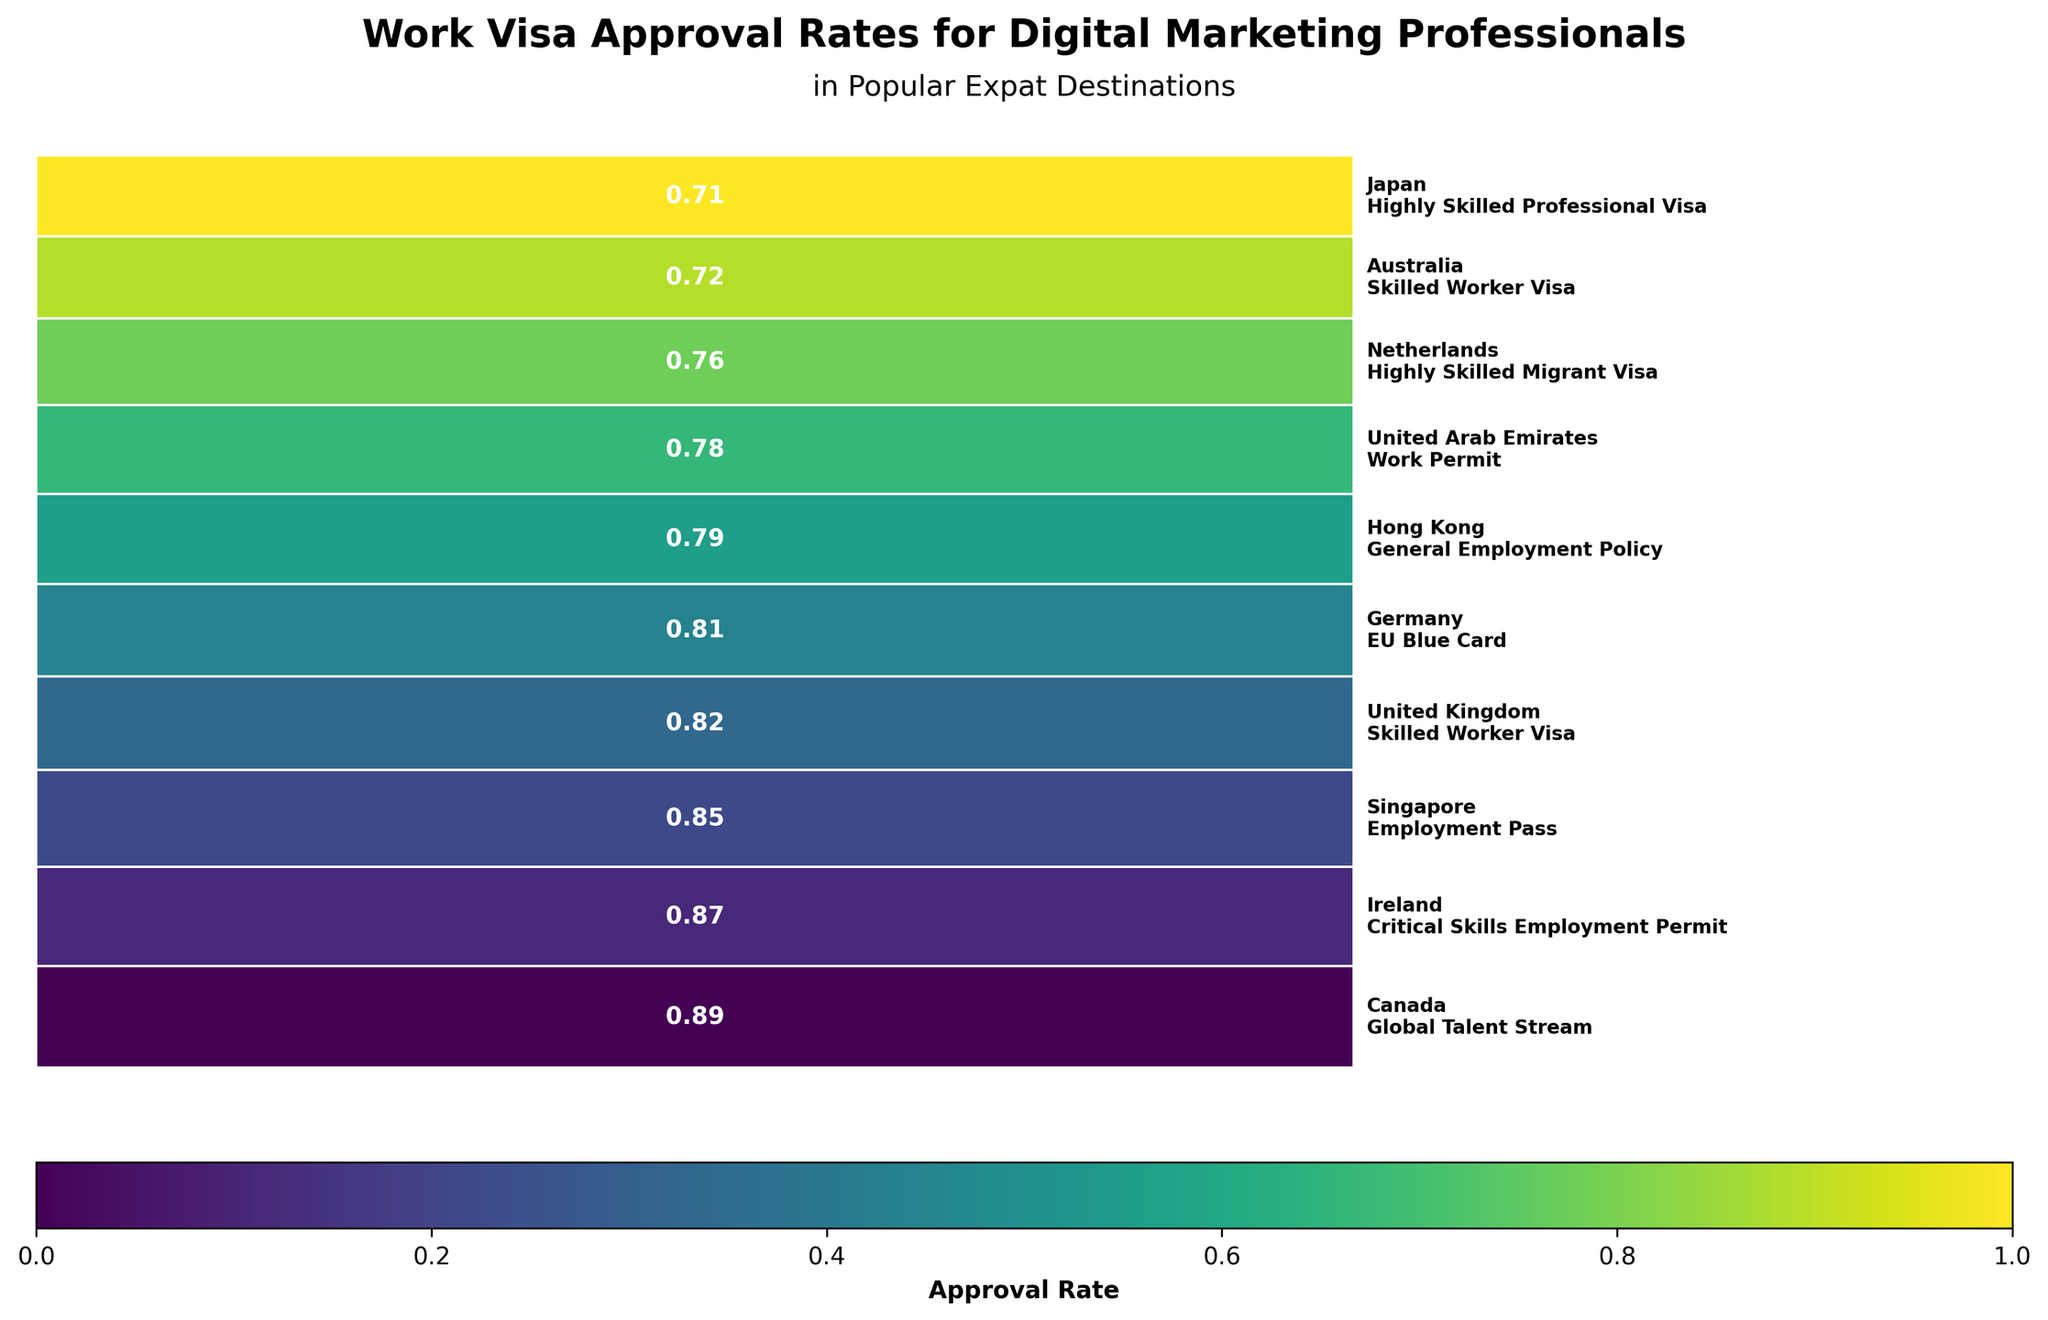Which country has the highest work visa approval rate for digital marketing professionals? First, find the country with the highest bar in the mosaic plot. The labels inside the bars provide the approval rates. The highest rate is labeled 0.89. This value corresponds to Canada.
Answer: Canada Which country and visa type combination has the lowest approval rate in the plot? Find the smallest bar in the mosaic plot and read the approval rate label from it. The value is 0.71 for Japan's Highly Skilled Professional Visa.
Answer: Japan, Highly Skilled Professional Visa How many countries have an approval rate of 0.80 or higher? Count the number of countries whose bars in the mosaic plot indicate a rate equal to or higher than 0.80. The countries are Canada (0.89), Ireland (0.87), Singapore (0.85), United Kingdom (0.82), and Germany (0.81).
Answer: 5 What is the difference in approval rates between the country with the highest rate and the country with the lowest rate? Identify the highest rate (Canada: 0.89) and the lowest rate (Japan: 0.71) and subtract the latter from the former (0.89 - 0.71).
Answer: 0.18 Which countries have approval rates between 0.75 and 0.80? Identify the countries with approval rates in this range by visually inspecting the bars. The countries are United Arab Emirates (0.78), Hong Kong (0.79), and Netherlands (0.76).
Answer: United Arab Emirates, Hong Kong, Netherlands Is the approval rate of the Critical Skills Employment Permit in Ireland higher than the Skilled Worker Visa in the United Kingdom? Compare the approval rates: Ireland's Critical Skills Employment Permit (0.87) and UK's Skilled Worker Visa (0.82). 0.87 is greater than 0.82.
Answer: Yes What is the combined approval rate of the top three countries? Find the approval rates of the top three countries: Canada (0.89), Ireland (0.87), and Singapore (0.85). Sum these rates (0.89 + 0.87 + 0.85).
Answer: 2.61 What is the median approval rate among all countries listed in the plot? Arrange the approval rates in order (0.71, 0.72, 0.76, 0.78, 0.79, 0.81, 0.82, 0.85, 0.87, 0.89). The median is the middle value in an ordered list. With 10 values, the median is the average of the 5th and 6th values (0.79 and 0.81), so (0.79 + 0.81)/2.
Answer: 0.80 Which visa type is associated with an approval rate of 0.76? Look at the mosaic plot to find the bar with a label of 0.76. The associated visa type is Highly Skilled Migrant Visa in the Netherlands.
Answer: Highly Skilled Migrant Visa (Netherlands) How many distinct visa types are represented in the plot? Count the unique visa types listed next to each country in the labels: Employment Pass, Work Permit, Skilled Worker Visa, Global Talent Stream, EU Blue Card, Highly Skilled Migrant Visa, General Employment Policy, Highly Skilled Professional Visa, Critical Skills Employment Permit. There are 9 unique visa types.
Answer: 9 